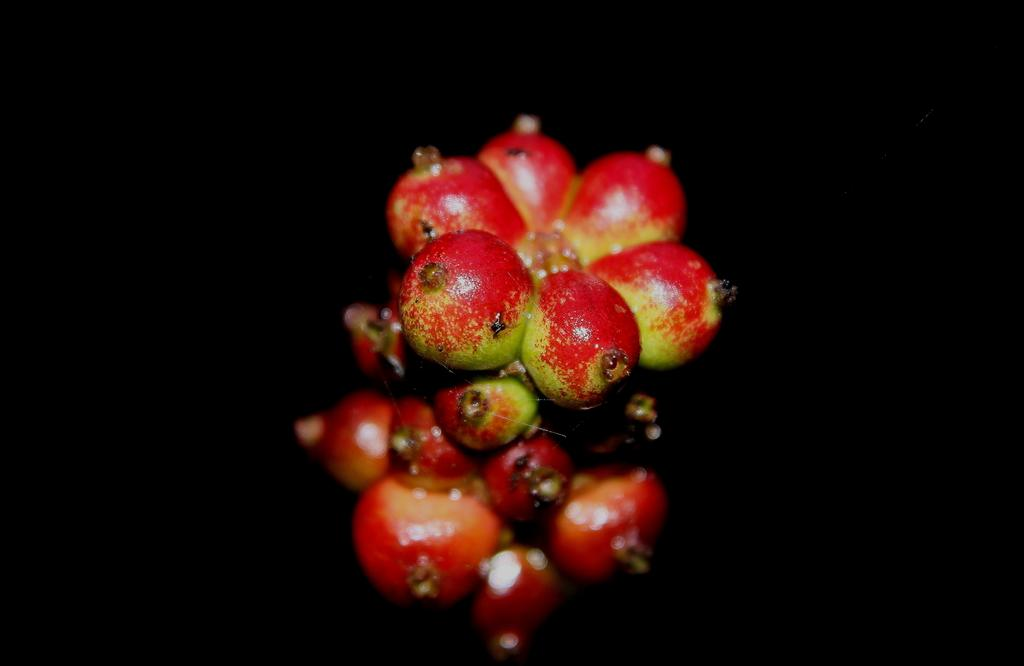What is the main subject of the image? The main subject of the image is a bunch of fruits. Can you describe the background of the image? The background of the image is dark. How much income does the cactus in the image generate? There is no cactus present in the image, so it is not possible to determine its income. 